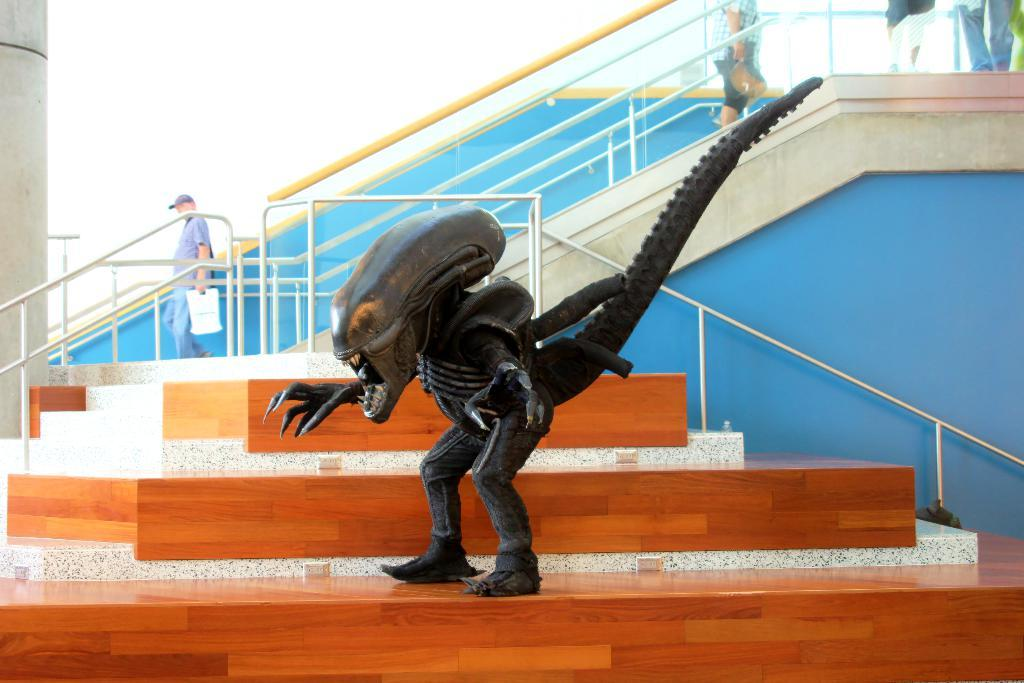What is the main subject in the center of the image? There is a statue in the center of the image. What can be seen in the background of the image? There are persons and a staircase visible in the background of the image. What is located on the left side of the image? There is a pillar on the left side of the image. What is the color of the wall in the image? The wall is blue in color. How many pizzas are being served to the army in the image? There are no pizzas or army members present in the image. What type of meat is being cooked on the grill in the image? There is no grill or meat present in the image. 